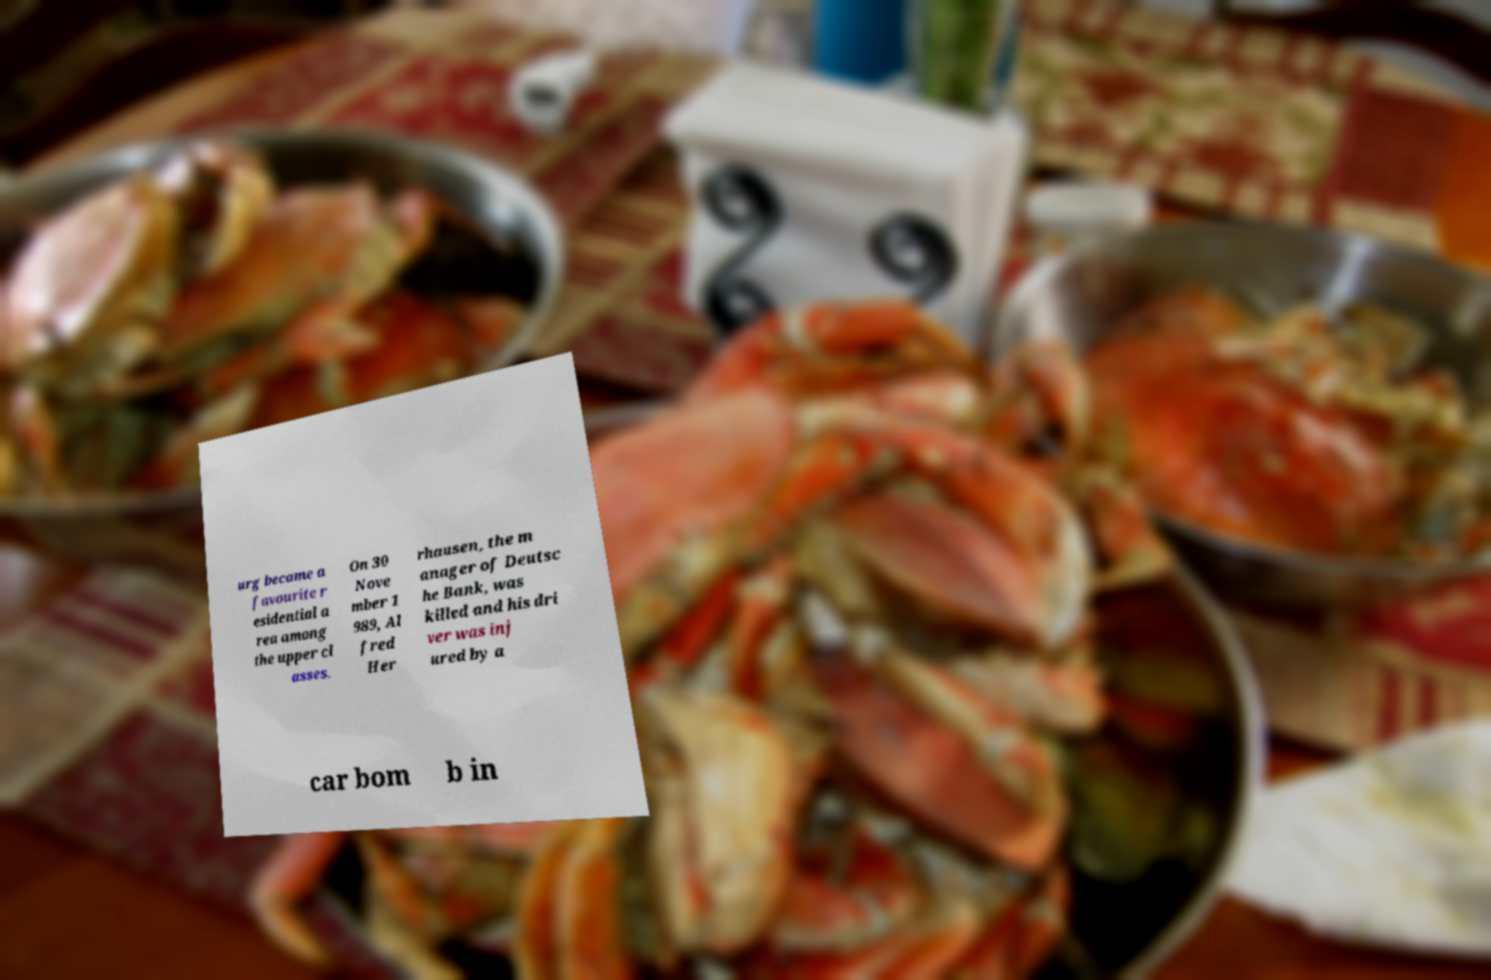For documentation purposes, I need the text within this image transcribed. Could you provide that? urg became a favourite r esidential a rea among the upper cl asses. On 30 Nove mber 1 989, Al fred Her rhausen, the m anager of Deutsc he Bank, was killed and his dri ver was inj ured by a car bom b in 